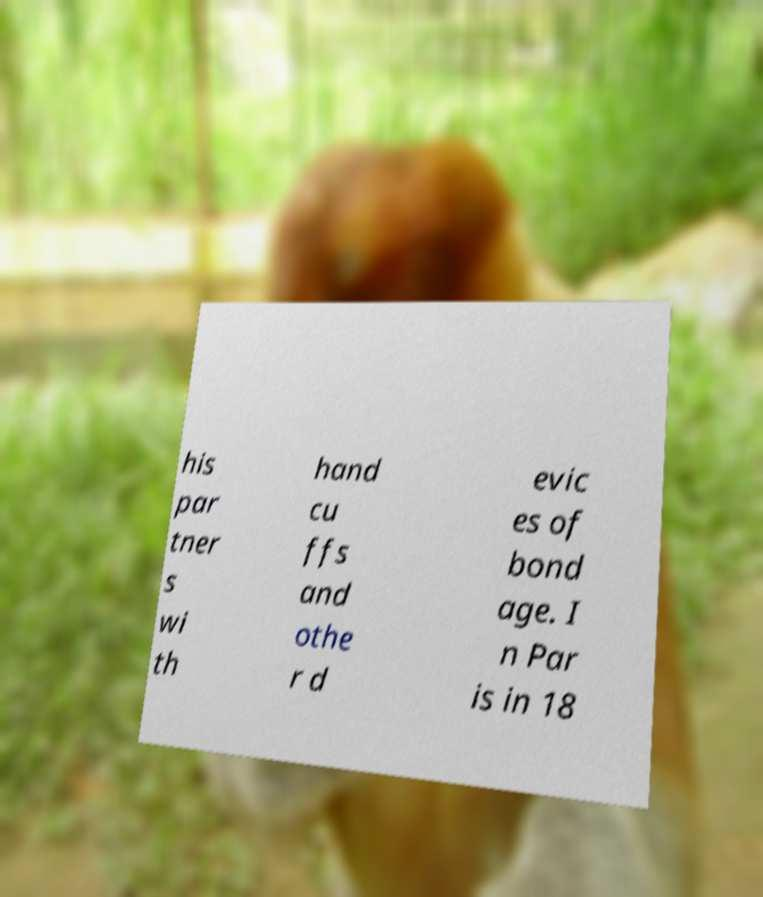Please identify and transcribe the text found in this image. his par tner s wi th hand cu ffs and othe r d evic es of bond age. I n Par is in 18 